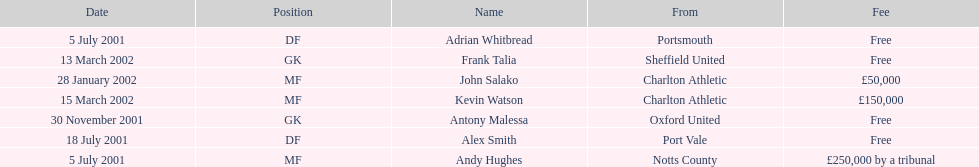Which player had the highest transfer fee, andy hughes or john salako? Andy Hughes. 